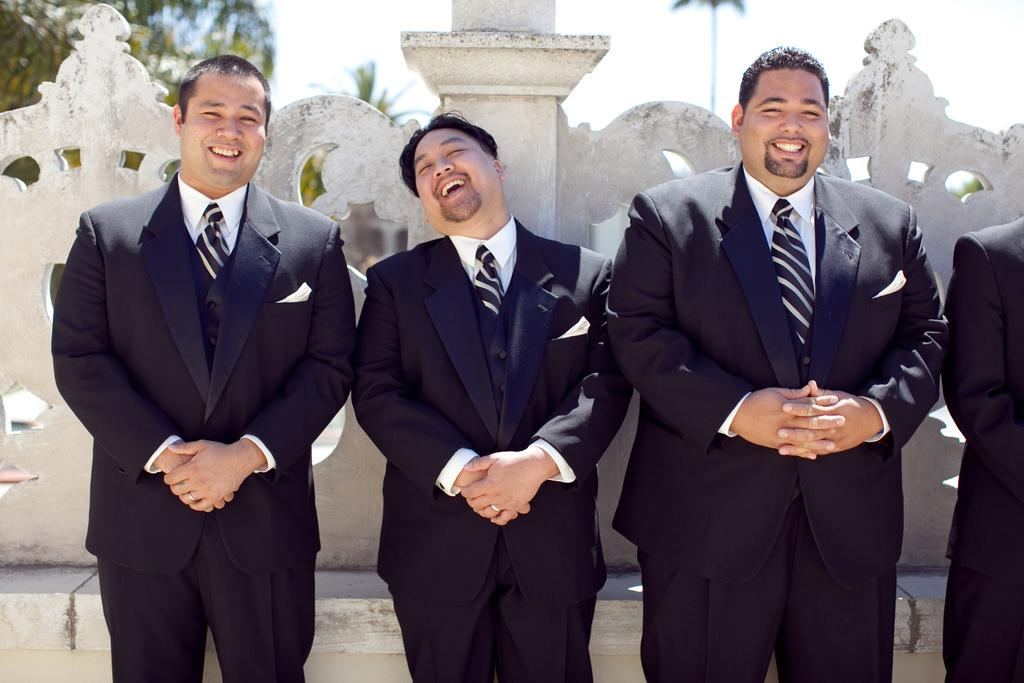What is the main subject of the image? The main subject of the image is a group of people. What are the people in the image doing? The people are smiling in the image. What are the people wearing in the image? The people are wearing black color suits in the image. What can be seen in the background of the image? There are trees in the background of the image. How many balls can be seen in the image? There are no balls present in the image. What type of giants are visible in the image? There are no giants present in the image. 